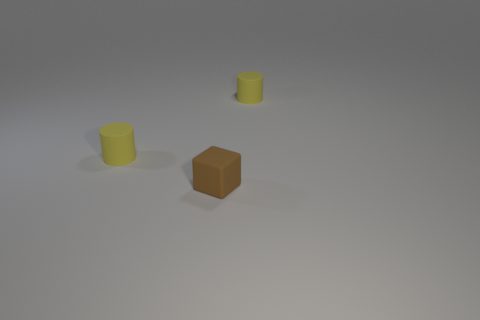Add 1 tiny yellow matte objects. How many objects exist? 4 Subtract 0 cyan spheres. How many objects are left? 3 Subtract all cylinders. How many objects are left? 1 Subtract 1 cylinders. How many cylinders are left? 1 Subtract all red cylinders. Subtract all green cubes. How many cylinders are left? 2 Subtract all gray shiny objects. Subtract all small yellow rubber cylinders. How many objects are left? 1 Add 1 brown matte cubes. How many brown matte cubes are left? 2 Add 1 tiny yellow cylinders. How many tiny yellow cylinders exist? 3 